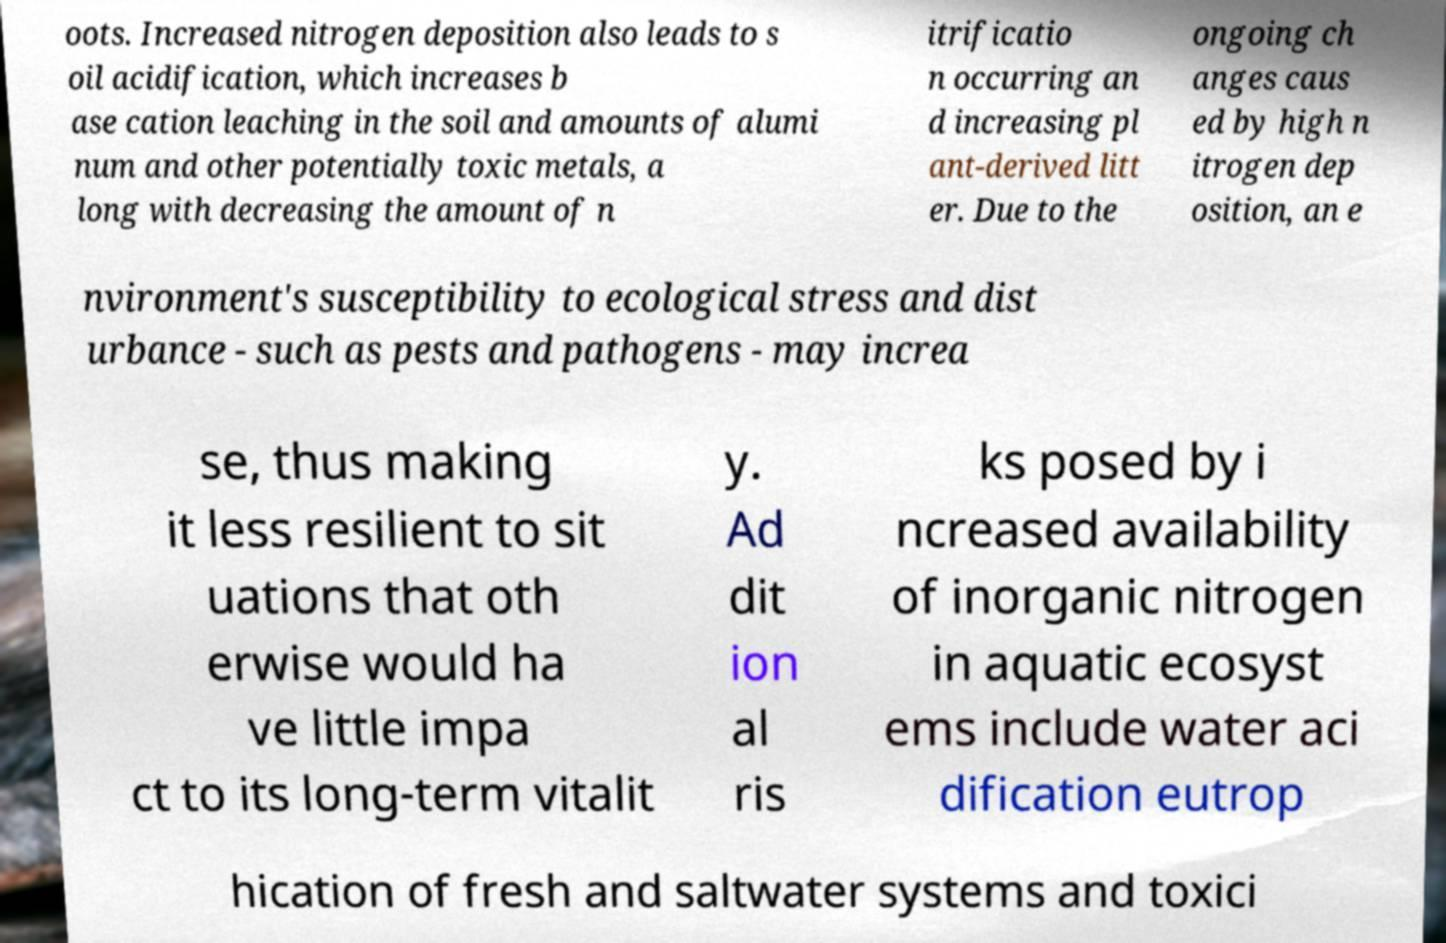I need the written content from this picture converted into text. Can you do that? oots. Increased nitrogen deposition also leads to s oil acidification, which increases b ase cation leaching in the soil and amounts of alumi num and other potentially toxic metals, a long with decreasing the amount of n itrificatio n occurring an d increasing pl ant-derived litt er. Due to the ongoing ch anges caus ed by high n itrogen dep osition, an e nvironment's susceptibility to ecological stress and dist urbance - such as pests and pathogens - may increa se, thus making it less resilient to sit uations that oth erwise would ha ve little impa ct to its long-term vitalit y. Ad dit ion al ris ks posed by i ncreased availability of inorganic nitrogen in aquatic ecosyst ems include water aci dification eutrop hication of fresh and saltwater systems and toxici 